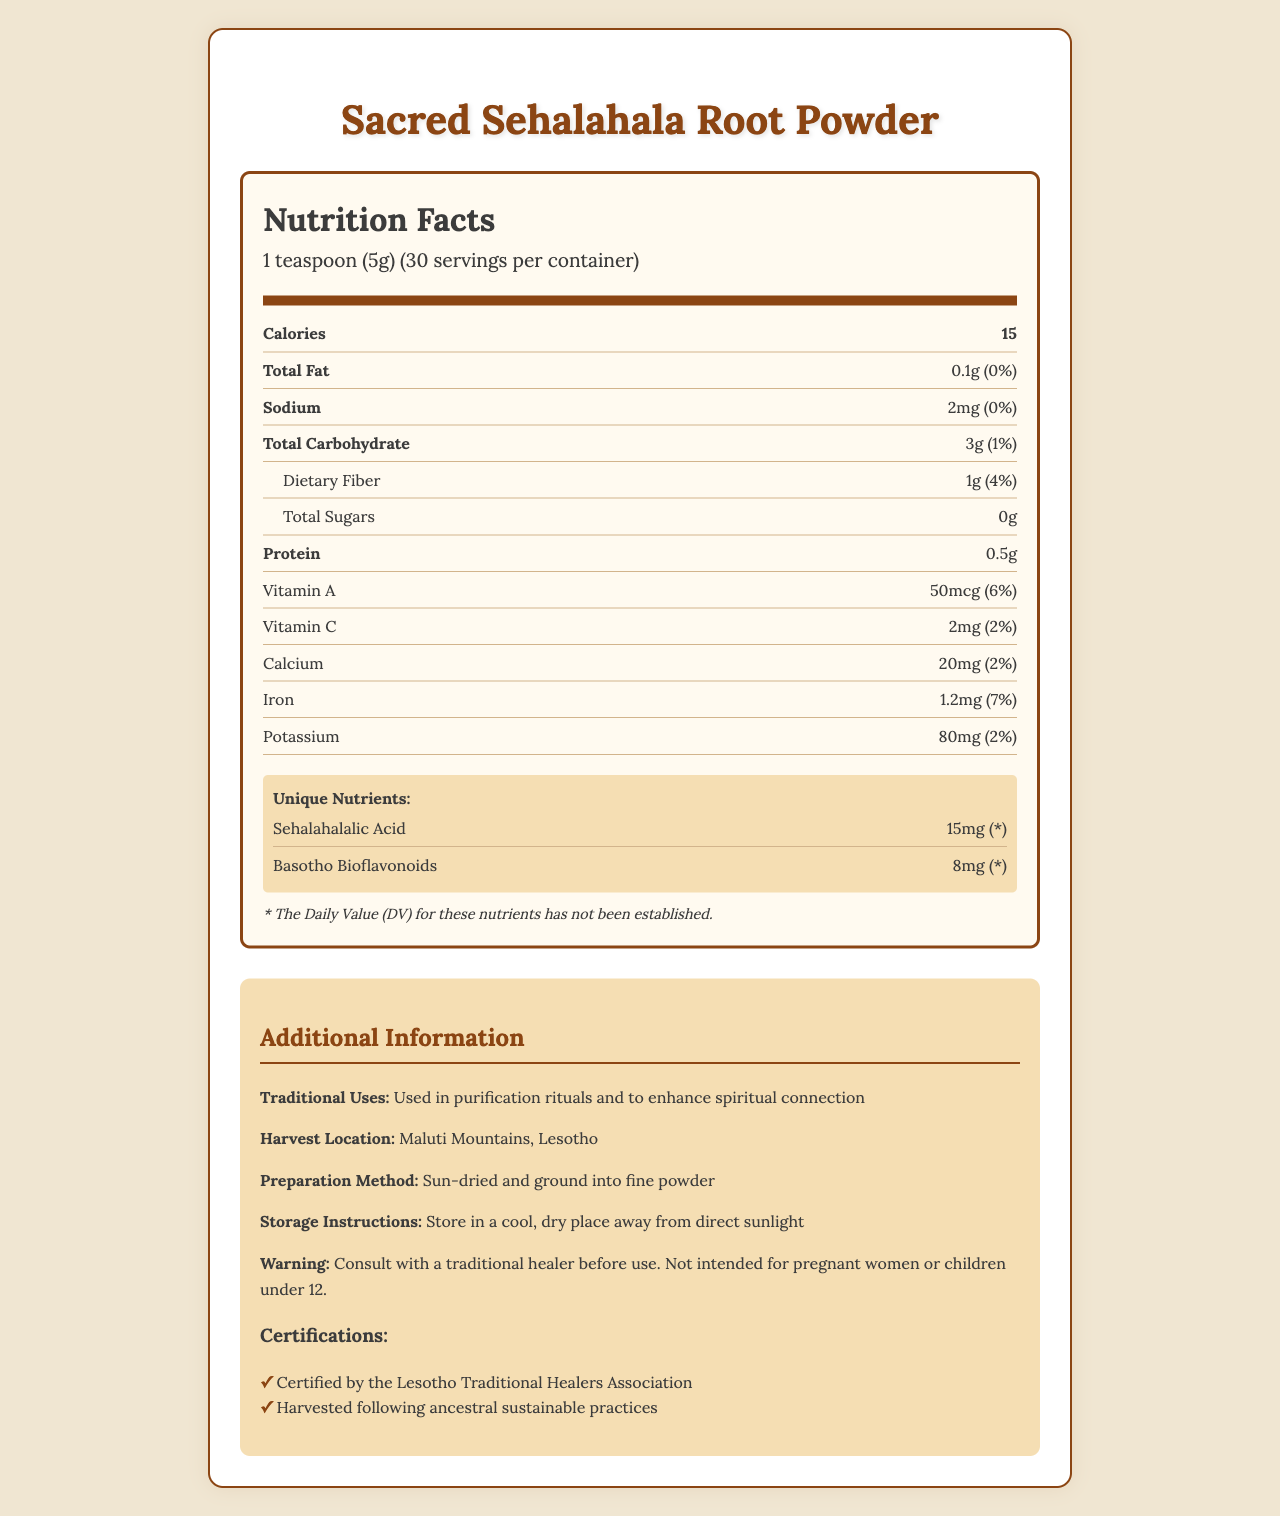what is the serving size of Sacred Sehalahala Root Powder? The document states that the serving size is 1 teaspoon (5g).
Answer: 1 teaspoon (5g) how many calories are there in one serving? According to the document, one serving contains 15 calories.
Answer: 15 what is the amount of total carbohydrates per serving? The document lists the total carbohydrates as 3g per serving.
Answer: 3g which vitamin is present in the highest amount per serving? The document states there is 50mcg of Vitamin A per serving, which is higher than the amount of any other vitamins listed.
Answer: Vitamin A what is the daily value percentage of dietary fiber provided per serving? The document states that dietary fiber amounts to 1g per serving, which is 4% of the daily value.
Answer: 4% what are the unique nutrients present in Sacred Sehalahala Root Powder? The document mentions Sehalahalalic Acid (15mg) and Basotho Bioflavonoids (8mg) as unique nutrients.
Answer: Sehalahalalic Acid, Basotho Bioflavonoids what is the main traditional use of Sacred Sehalahala Root Powder? The document states that it is used in purification rituals and to enhance spiritual connection.
Answer: Purification rituals and enhancing spiritual connection where is the Sacred Sehalahala Root harvested? The document specifies that it is harvested in the Maluti Mountains, Lesotho.
Answer: Maluti Mountains, Lesotho how many servings are there in one container? The document states that there are 30 servings per container.
Answer: 30 what caution is advised before using Sacred Sehalahala Root Powder? The document advises consultation with a traditional healer before use and warns that it is not intended for pregnant women or children under 12.
Answer: Consult with a traditional healer before use. Not intended for pregnant women or children under 12. which certification does Sacred Sehalahala Root Powder have? A. Organic Certified B. Certified by the Lesotho Traditional Healers Association C. Non-GMO Certified The document lists "Certified by the Lesotho Traditional Healers Association" as a certification.
Answer: B what is the daily value percentage of iron provided per serving? A. 2% B. 4% C. 7% The document states that the iron content per serving is 1.2mg, which is 7% of the daily value.
Answer: C is the total amount of sugars in a serving non-existent? Yes/No The document indicates that the total sugars amount to 0g per serving.
Answer: Yes describe the origin and preparation method of Sacred Sehalahala Root Powder. The document explains that the plant is harvested in the Maluti Mountains, Lesotho, and is prepared by sun drying and grinding it into a fine powder.
Answer: The Sacred Sehalahala Root Powder is harvested from the Maluti Mountains in Lesotho. It is sun-dried and ground into a fine powder. what are the benefits of Basotho Bioflavonoids? The document lists Basotho Bioflavonoids as a unique nutrient, but does not provide specific information on the benefits.
Answer: Not enough information 